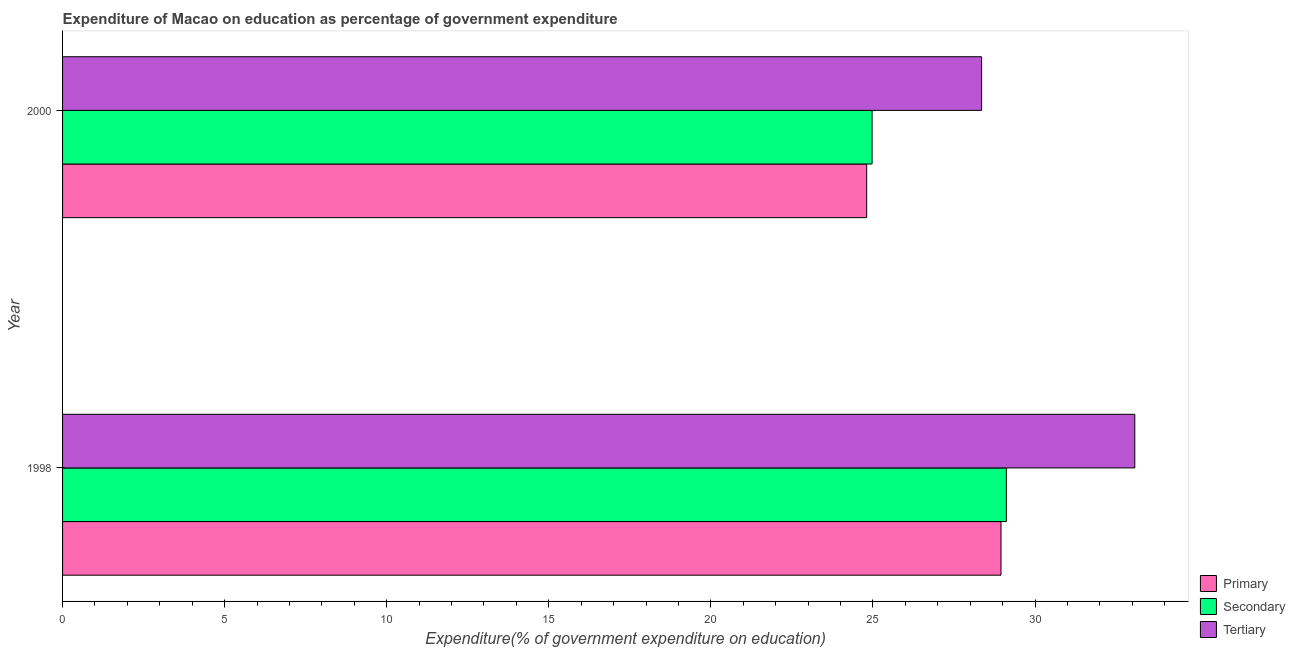How many different coloured bars are there?
Make the answer very short. 3. Are the number of bars per tick equal to the number of legend labels?
Make the answer very short. Yes. Are the number of bars on each tick of the Y-axis equal?
Keep it short and to the point. Yes. How many bars are there on the 2nd tick from the top?
Your answer should be compact. 3. What is the expenditure on primary education in 1998?
Offer a terse response. 28.95. Across all years, what is the maximum expenditure on secondary education?
Your answer should be compact. 29.11. Across all years, what is the minimum expenditure on secondary education?
Provide a succinct answer. 24.97. What is the total expenditure on primary education in the graph?
Your answer should be compact. 53.75. What is the difference between the expenditure on tertiary education in 1998 and that in 2000?
Provide a succinct answer. 4.73. What is the difference between the expenditure on primary education in 2000 and the expenditure on tertiary education in 1998?
Give a very brief answer. -8.27. What is the average expenditure on primary education per year?
Ensure brevity in your answer.  26.88. In the year 2000, what is the difference between the expenditure on primary education and expenditure on tertiary education?
Offer a very short reply. -3.54. In how many years, is the expenditure on secondary education greater than 28 %?
Provide a short and direct response. 1. What is the ratio of the expenditure on tertiary education in 1998 to that in 2000?
Ensure brevity in your answer.  1.17. What does the 3rd bar from the top in 2000 represents?
Ensure brevity in your answer.  Primary. What does the 2nd bar from the bottom in 2000 represents?
Your answer should be very brief. Secondary. How many bars are there?
Your answer should be compact. 6. Are all the bars in the graph horizontal?
Your answer should be very brief. Yes. How many years are there in the graph?
Provide a succinct answer. 2. Are the values on the major ticks of X-axis written in scientific E-notation?
Provide a succinct answer. No. Does the graph contain any zero values?
Offer a terse response. No. Does the graph contain grids?
Provide a succinct answer. No. Where does the legend appear in the graph?
Offer a terse response. Bottom right. How many legend labels are there?
Offer a terse response. 3. What is the title of the graph?
Ensure brevity in your answer.  Expenditure of Macao on education as percentage of government expenditure. What is the label or title of the X-axis?
Provide a short and direct response. Expenditure(% of government expenditure on education). What is the label or title of the Y-axis?
Keep it short and to the point. Year. What is the Expenditure(% of government expenditure on education) in Primary in 1998?
Give a very brief answer. 28.95. What is the Expenditure(% of government expenditure on education) of Secondary in 1998?
Give a very brief answer. 29.11. What is the Expenditure(% of government expenditure on education) of Tertiary in 1998?
Keep it short and to the point. 33.08. What is the Expenditure(% of government expenditure on education) of Primary in 2000?
Give a very brief answer. 24.81. What is the Expenditure(% of government expenditure on education) of Secondary in 2000?
Make the answer very short. 24.97. What is the Expenditure(% of government expenditure on education) of Tertiary in 2000?
Provide a succinct answer. 28.35. Across all years, what is the maximum Expenditure(% of government expenditure on education) in Primary?
Make the answer very short. 28.95. Across all years, what is the maximum Expenditure(% of government expenditure on education) in Secondary?
Your response must be concise. 29.11. Across all years, what is the maximum Expenditure(% of government expenditure on education) of Tertiary?
Your answer should be very brief. 33.08. Across all years, what is the minimum Expenditure(% of government expenditure on education) in Primary?
Offer a terse response. 24.81. Across all years, what is the minimum Expenditure(% of government expenditure on education) of Secondary?
Keep it short and to the point. 24.97. Across all years, what is the minimum Expenditure(% of government expenditure on education) in Tertiary?
Your answer should be very brief. 28.35. What is the total Expenditure(% of government expenditure on education) in Primary in the graph?
Offer a terse response. 53.75. What is the total Expenditure(% of government expenditure on education) of Secondary in the graph?
Your answer should be compact. 54.09. What is the total Expenditure(% of government expenditure on education) in Tertiary in the graph?
Your answer should be very brief. 61.43. What is the difference between the Expenditure(% of government expenditure on education) in Primary in 1998 and that in 2000?
Provide a short and direct response. 4.14. What is the difference between the Expenditure(% of government expenditure on education) of Secondary in 1998 and that in 2000?
Your response must be concise. 4.14. What is the difference between the Expenditure(% of government expenditure on education) in Tertiary in 1998 and that in 2000?
Your answer should be very brief. 4.73. What is the difference between the Expenditure(% of government expenditure on education) in Primary in 1998 and the Expenditure(% of government expenditure on education) in Secondary in 2000?
Offer a terse response. 3.98. What is the difference between the Expenditure(% of government expenditure on education) in Primary in 1998 and the Expenditure(% of government expenditure on education) in Tertiary in 2000?
Make the answer very short. 0.6. What is the difference between the Expenditure(% of government expenditure on education) of Secondary in 1998 and the Expenditure(% of government expenditure on education) of Tertiary in 2000?
Keep it short and to the point. 0.76. What is the average Expenditure(% of government expenditure on education) in Primary per year?
Keep it short and to the point. 26.88. What is the average Expenditure(% of government expenditure on education) of Secondary per year?
Provide a short and direct response. 27.04. What is the average Expenditure(% of government expenditure on education) of Tertiary per year?
Provide a short and direct response. 30.71. In the year 1998, what is the difference between the Expenditure(% of government expenditure on education) in Primary and Expenditure(% of government expenditure on education) in Secondary?
Give a very brief answer. -0.17. In the year 1998, what is the difference between the Expenditure(% of government expenditure on education) in Primary and Expenditure(% of government expenditure on education) in Tertiary?
Ensure brevity in your answer.  -4.13. In the year 1998, what is the difference between the Expenditure(% of government expenditure on education) in Secondary and Expenditure(% of government expenditure on education) in Tertiary?
Offer a very short reply. -3.96. In the year 2000, what is the difference between the Expenditure(% of government expenditure on education) in Primary and Expenditure(% of government expenditure on education) in Secondary?
Provide a succinct answer. -0.17. In the year 2000, what is the difference between the Expenditure(% of government expenditure on education) of Primary and Expenditure(% of government expenditure on education) of Tertiary?
Offer a very short reply. -3.54. In the year 2000, what is the difference between the Expenditure(% of government expenditure on education) in Secondary and Expenditure(% of government expenditure on education) in Tertiary?
Your answer should be very brief. -3.38. What is the ratio of the Expenditure(% of government expenditure on education) of Primary in 1998 to that in 2000?
Make the answer very short. 1.17. What is the ratio of the Expenditure(% of government expenditure on education) in Secondary in 1998 to that in 2000?
Offer a very short reply. 1.17. What is the ratio of the Expenditure(% of government expenditure on education) of Tertiary in 1998 to that in 2000?
Keep it short and to the point. 1.17. What is the difference between the highest and the second highest Expenditure(% of government expenditure on education) in Primary?
Ensure brevity in your answer.  4.14. What is the difference between the highest and the second highest Expenditure(% of government expenditure on education) in Secondary?
Your answer should be compact. 4.14. What is the difference between the highest and the second highest Expenditure(% of government expenditure on education) in Tertiary?
Provide a succinct answer. 4.73. What is the difference between the highest and the lowest Expenditure(% of government expenditure on education) in Primary?
Your answer should be compact. 4.14. What is the difference between the highest and the lowest Expenditure(% of government expenditure on education) of Secondary?
Your answer should be compact. 4.14. What is the difference between the highest and the lowest Expenditure(% of government expenditure on education) in Tertiary?
Offer a terse response. 4.73. 